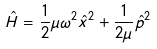<formula> <loc_0><loc_0><loc_500><loc_500>\hat { H } = \frac { 1 } { 2 } \mu \omega ^ { 2 } \hat { x } ^ { 2 } + \frac { 1 } { 2 \mu } \hat { p } ^ { 2 }</formula> 